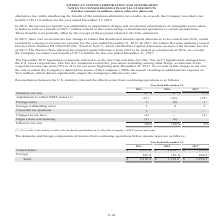According to American Tower Corporation's financial document, What was the income from continuing operations before income taxes from United States in 2019? According to the financial document, $1,527.0 (in millions). The relevant text states: "United States $ 1,527.0 $ 1,212.7 $ 971.2..." Also, What was the income from continuing operations before income taxes from Foreign sources in 2018? According to the financial document, (58.1) (in millions). The relevant text states: "Foreign 389.4 (58.1) 284.9..." Also, What was the total income from continuing operations before income taxes in 2018? According to the financial document, $1,154.6 (in millions). The relevant text states: "Total $ 1,916.4 $ 1,154.6 $ 1,256.1..." Also, How many years did income from continuing operations before income taxes from the United States exceed $1,000 million? Counting the relevant items in the document: 2019, 2018, I find 2 instances. The key data points involved are: 2018, 2019. Also, How many years did total income from continuing operations before income taxes exceed $1,000 million? Counting the relevant items in the document: 2019, 2018, 2017, I find 3 instances. The key data points involved are: 2017, 2018, 2019. Also, can you calculate: What was the percentage change in total income from continuing operations before income taxes between 2018 and 2019? To answer this question, I need to perform calculations using the financial data. The calculation is: ($1,916.4-$1,154.6)/$1,154.6, which equals 65.98 (percentage). This is based on the information: "Total $ 1,916.4 $ 1,154.6 $ 1,256.1 Total $ 1,916.4 $ 1,154.6 $ 1,256.1..." The key data points involved are: 1,154.6, 1,916.4. 